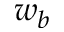<formula> <loc_0><loc_0><loc_500><loc_500>w _ { b }</formula> 